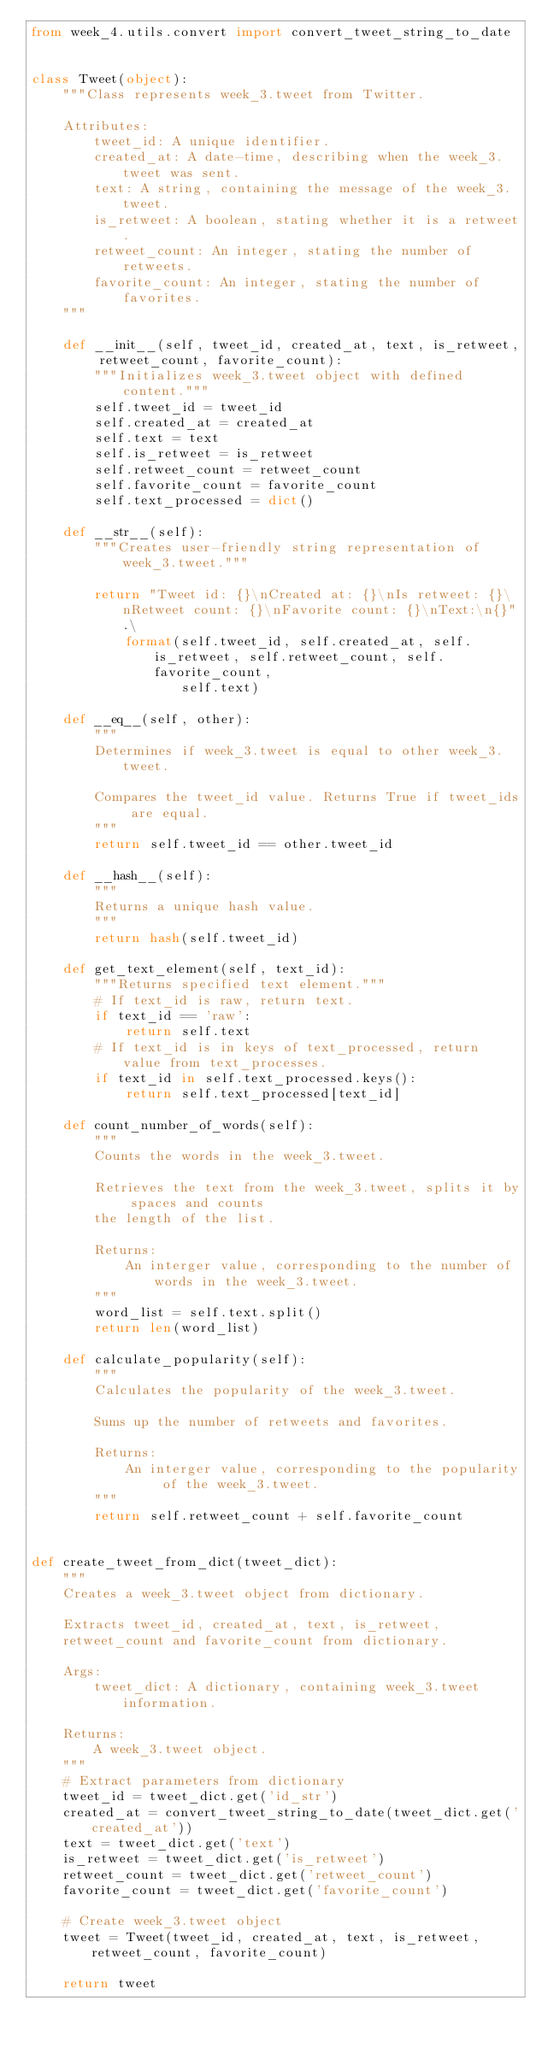Convert code to text. <code><loc_0><loc_0><loc_500><loc_500><_Python_>from week_4.utils.convert import convert_tweet_string_to_date


class Tweet(object):
    """Class represents week_3.tweet from Twitter.

    Attributes:
        tweet_id: A unique identifier.
        created_at: A date-time, describing when the week_3.tweet was sent.
        text: A string, containing the message of the week_3.tweet.
        is_retweet: A boolean, stating whether it is a retweet.
        retweet_count: An integer, stating the number of retweets.
        favorite_count: An integer, stating the number of favorites.
    """

    def __init__(self, tweet_id, created_at, text, is_retweet, retweet_count, favorite_count):
        """Initializes week_3.tweet object with defined content."""
        self.tweet_id = tweet_id
        self.created_at = created_at
        self.text = text
        self.is_retweet = is_retweet
        self.retweet_count = retweet_count
        self.favorite_count = favorite_count
        self.text_processed = dict()

    def __str__(self):
        """Creates user-friendly string representation of week_3.tweet."""

        return "Tweet id: {}\nCreated at: {}\nIs retweet: {}\nRetweet count: {}\nFavorite count: {}\nText:\n{}".\
            format(self.tweet_id, self.created_at, self.is_retweet, self.retweet_count, self.favorite_count,
                   self.text)

    def __eq__(self, other):
        """
        Determines if week_3.tweet is equal to other week_3.tweet.

        Compares the tweet_id value. Returns True if tweet_ids are equal.
        """
        return self.tweet_id == other.tweet_id

    def __hash__(self):
        """
        Returns a unique hash value.
        """
        return hash(self.tweet_id)

    def get_text_element(self, text_id):
        """Returns specified text element."""
        # If text_id is raw, return text.
        if text_id == 'raw':
            return self.text
        # If text_id is in keys of text_processed, return value from text_processes.
        if text_id in self.text_processed.keys():
            return self.text_processed[text_id]

    def count_number_of_words(self):
        """
        Counts the words in the week_3.tweet.

        Retrieves the text from the week_3.tweet, splits it by spaces and counts
        the length of the list.

        Returns:
            An interger value, corresponding to the number of words in the week_3.tweet.
        """
        word_list = self.text.split()
        return len(word_list)

    def calculate_popularity(self):
        """
        Calculates the popularity of the week_3.tweet.

        Sums up the number of retweets and favorites.

        Returns:
            An interger value, corresponding to the popularity of the week_3.tweet.
        """
        return self.retweet_count + self.favorite_count


def create_tweet_from_dict(tweet_dict):
    """
    Creates a week_3.tweet object from dictionary.

    Extracts tweet_id, created_at, text, is_retweet,
    retweet_count and favorite_count from dictionary.

    Args:
        tweet_dict: A dictionary, containing week_3.tweet information.

    Returns:
        A week_3.tweet object.
    """
    # Extract parameters from dictionary
    tweet_id = tweet_dict.get('id_str')
    created_at = convert_tweet_string_to_date(tweet_dict.get('created_at'))
    text = tweet_dict.get('text')
    is_retweet = tweet_dict.get('is_retweet')
    retweet_count = tweet_dict.get('retweet_count')
    favorite_count = tweet_dict.get('favorite_count')

    # Create week_3.tweet object
    tweet = Tweet(tweet_id, created_at, text, is_retweet, retweet_count, favorite_count)

    return tweet
</code> 